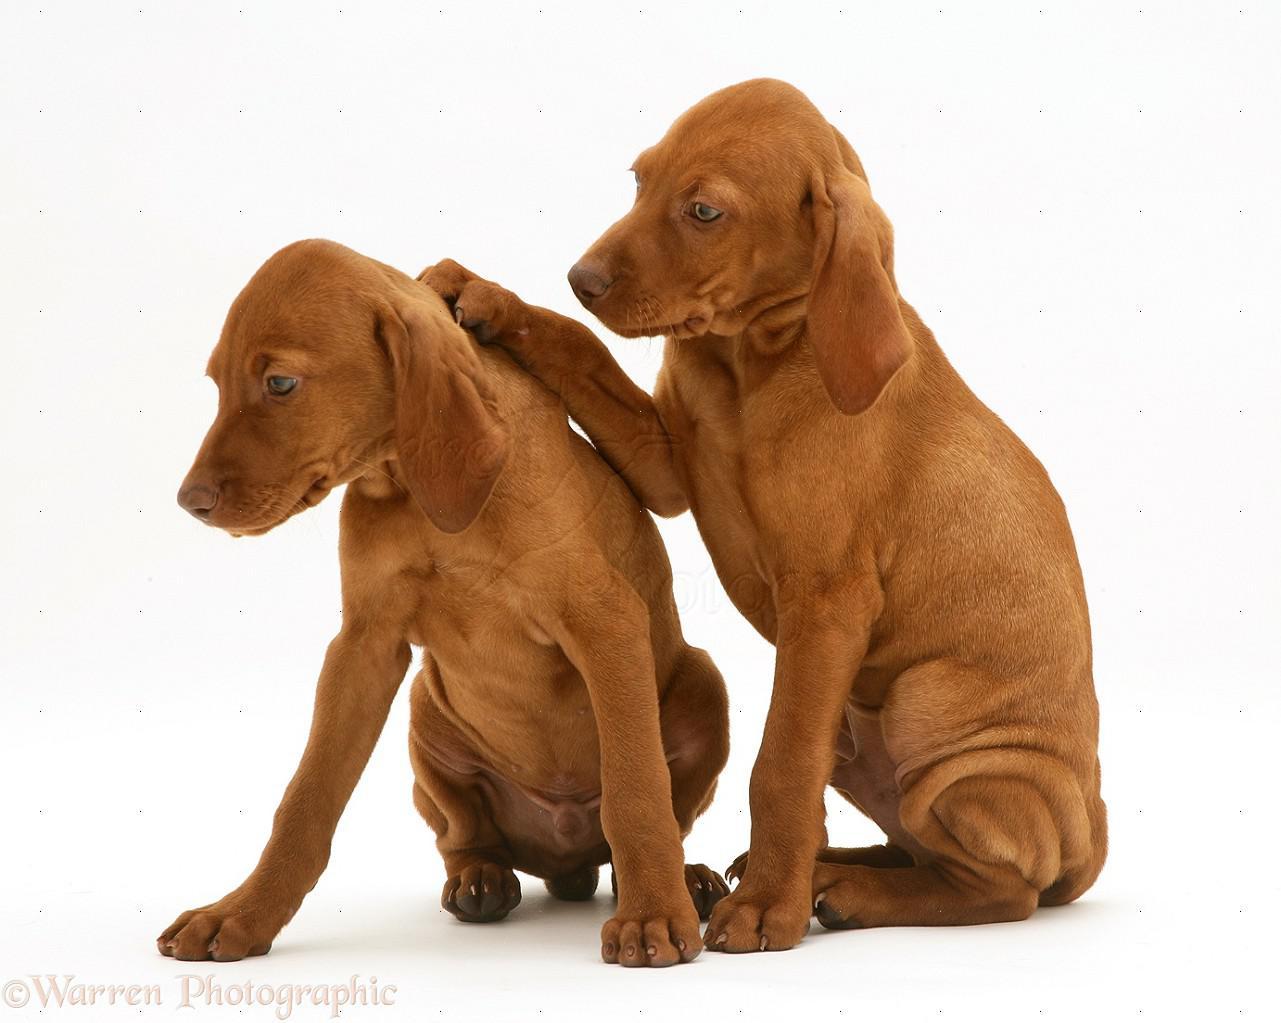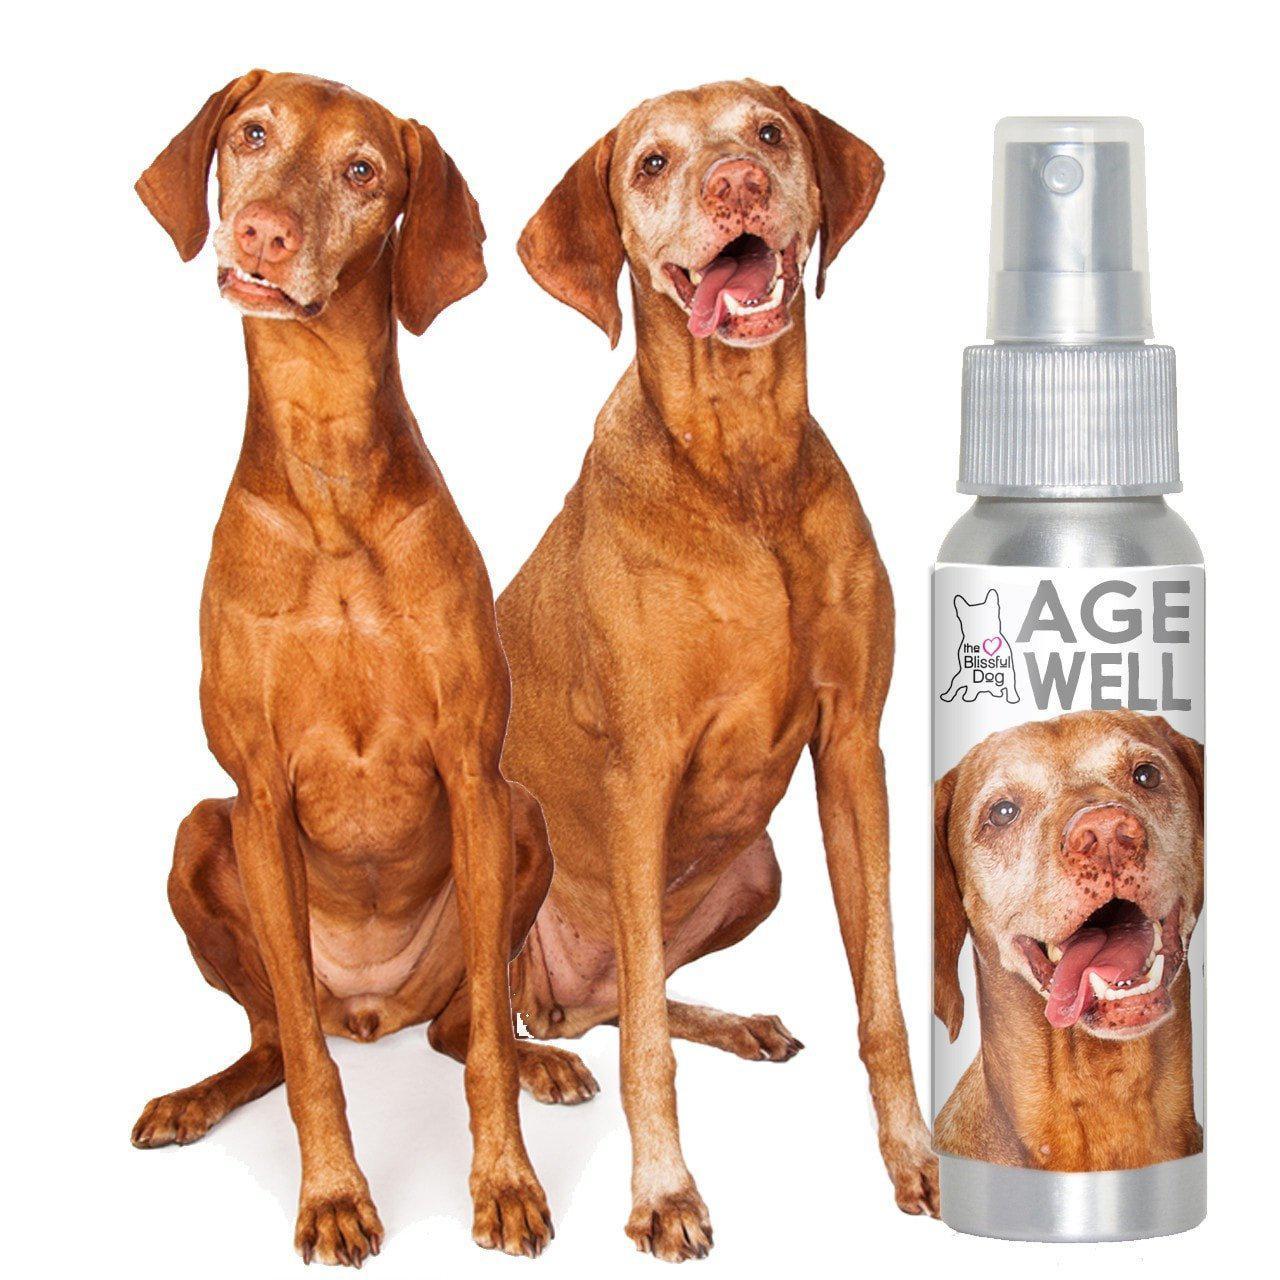The first image is the image on the left, the second image is the image on the right. Examine the images to the left and right. Is the description "The left image shows two leftward-facing red-orange dogs, and at least one of them is sitting upright." accurate? Answer yes or no. Yes. 